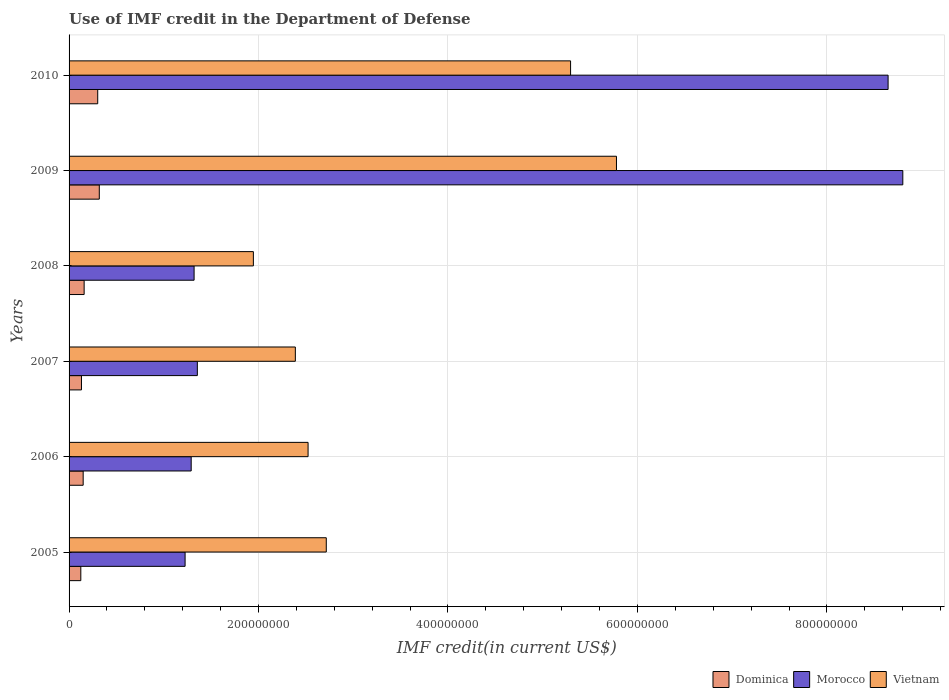How many groups of bars are there?
Your answer should be compact. 6. Are the number of bars per tick equal to the number of legend labels?
Your response must be concise. Yes. Are the number of bars on each tick of the Y-axis equal?
Provide a short and direct response. Yes. How many bars are there on the 5th tick from the bottom?
Offer a terse response. 3. What is the IMF credit in the Department of Defense in Morocco in 2010?
Offer a very short reply. 8.65e+08. Across all years, what is the maximum IMF credit in the Department of Defense in Dominica?
Your response must be concise. 3.19e+07. Across all years, what is the minimum IMF credit in the Department of Defense in Vietnam?
Your response must be concise. 1.95e+08. In which year was the IMF credit in the Department of Defense in Dominica maximum?
Offer a terse response. 2009. What is the total IMF credit in the Department of Defense in Morocco in the graph?
Your response must be concise. 2.26e+09. What is the difference between the IMF credit in the Department of Defense in Vietnam in 2007 and that in 2009?
Give a very brief answer. -3.39e+08. What is the difference between the IMF credit in the Department of Defense in Morocco in 2008 and the IMF credit in the Department of Defense in Dominica in 2007?
Keep it short and to the point. 1.19e+08. What is the average IMF credit in the Department of Defense in Morocco per year?
Your answer should be very brief. 3.77e+08. In the year 2007, what is the difference between the IMF credit in the Department of Defense in Dominica and IMF credit in the Department of Defense in Morocco?
Keep it short and to the point. -1.22e+08. What is the ratio of the IMF credit in the Department of Defense in Morocco in 2009 to that in 2010?
Make the answer very short. 1.02. Is the IMF credit in the Department of Defense in Vietnam in 2006 less than that in 2007?
Ensure brevity in your answer.  No. What is the difference between the highest and the second highest IMF credit in the Department of Defense in Vietnam?
Ensure brevity in your answer.  4.84e+07. What is the difference between the highest and the lowest IMF credit in the Department of Defense in Dominica?
Make the answer very short. 1.95e+07. What does the 2nd bar from the top in 2005 represents?
Your answer should be very brief. Morocco. What does the 3rd bar from the bottom in 2007 represents?
Offer a terse response. Vietnam. Is it the case that in every year, the sum of the IMF credit in the Department of Defense in Dominica and IMF credit in the Department of Defense in Vietnam is greater than the IMF credit in the Department of Defense in Morocco?
Give a very brief answer. No. Are all the bars in the graph horizontal?
Ensure brevity in your answer.  Yes. What is the difference between two consecutive major ticks on the X-axis?
Keep it short and to the point. 2.00e+08. Are the values on the major ticks of X-axis written in scientific E-notation?
Provide a short and direct response. No. Does the graph contain any zero values?
Offer a very short reply. No. Where does the legend appear in the graph?
Your answer should be compact. Bottom right. How are the legend labels stacked?
Give a very brief answer. Horizontal. What is the title of the graph?
Offer a terse response. Use of IMF credit in the Department of Defense. Does "Haiti" appear as one of the legend labels in the graph?
Give a very brief answer. No. What is the label or title of the X-axis?
Provide a short and direct response. IMF credit(in current US$). What is the label or title of the Y-axis?
Your answer should be compact. Years. What is the IMF credit(in current US$) of Dominica in 2005?
Offer a very short reply. 1.24e+07. What is the IMF credit(in current US$) in Morocco in 2005?
Offer a very short reply. 1.22e+08. What is the IMF credit(in current US$) of Vietnam in 2005?
Your response must be concise. 2.72e+08. What is the IMF credit(in current US$) in Dominica in 2006?
Ensure brevity in your answer.  1.49e+07. What is the IMF credit(in current US$) in Morocco in 2006?
Provide a short and direct response. 1.29e+08. What is the IMF credit(in current US$) in Vietnam in 2006?
Your answer should be compact. 2.52e+08. What is the IMF credit(in current US$) in Dominica in 2007?
Provide a short and direct response. 1.31e+07. What is the IMF credit(in current US$) of Morocco in 2007?
Offer a very short reply. 1.35e+08. What is the IMF credit(in current US$) in Vietnam in 2007?
Your answer should be compact. 2.39e+08. What is the IMF credit(in current US$) of Dominica in 2008?
Provide a succinct answer. 1.59e+07. What is the IMF credit(in current US$) in Morocco in 2008?
Your answer should be compact. 1.32e+08. What is the IMF credit(in current US$) in Vietnam in 2008?
Make the answer very short. 1.95e+08. What is the IMF credit(in current US$) of Dominica in 2009?
Your answer should be compact. 3.19e+07. What is the IMF credit(in current US$) in Morocco in 2009?
Keep it short and to the point. 8.80e+08. What is the IMF credit(in current US$) of Vietnam in 2009?
Your response must be concise. 5.78e+08. What is the IMF credit(in current US$) in Dominica in 2010?
Ensure brevity in your answer.  3.02e+07. What is the IMF credit(in current US$) of Morocco in 2010?
Keep it short and to the point. 8.65e+08. What is the IMF credit(in current US$) of Vietnam in 2010?
Provide a short and direct response. 5.29e+08. Across all years, what is the maximum IMF credit(in current US$) in Dominica?
Your answer should be compact. 3.19e+07. Across all years, what is the maximum IMF credit(in current US$) of Morocco?
Your answer should be very brief. 8.80e+08. Across all years, what is the maximum IMF credit(in current US$) in Vietnam?
Offer a very short reply. 5.78e+08. Across all years, what is the minimum IMF credit(in current US$) of Dominica?
Provide a succinct answer. 1.24e+07. Across all years, what is the minimum IMF credit(in current US$) in Morocco?
Give a very brief answer. 1.22e+08. Across all years, what is the minimum IMF credit(in current US$) of Vietnam?
Provide a short and direct response. 1.95e+08. What is the total IMF credit(in current US$) of Dominica in the graph?
Your response must be concise. 1.18e+08. What is the total IMF credit(in current US$) in Morocco in the graph?
Make the answer very short. 2.26e+09. What is the total IMF credit(in current US$) of Vietnam in the graph?
Your response must be concise. 2.06e+09. What is the difference between the IMF credit(in current US$) in Dominica in 2005 and that in 2006?
Your answer should be compact. -2.49e+06. What is the difference between the IMF credit(in current US$) in Morocco in 2005 and that in 2006?
Offer a terse response. -6.44e+06. What is the difference between the IMF credit(in current US$) in Vietnam in 2005 and that in 2006?
Provide a succinct answer. 1.92e+07. What is the difference between the IMF credit(in current US$) in Dominica in 2005 and that in 2007?
Give a very brief answer. -6.87e+05. What is the difference between the IMF credit(in current US$) of Morocco in 2005 and that in 2007?
Your answer should be compact. -1.29e+07. What is the difference between the IMF credit(in current US$) of Vietnam in 2005 and that in 2007?
Give a very brief answer. 3.27e+07. What is the difference between the IMF credit(in current US$) in Dominica in 2005 and that in 2008?
Ensure brevity in your answer.  -3.51e+06. What is the difference between the IMF credit(in current US$) of Morocco in 2005 and that in 2008?
Keep it short and to the point. -9.51e+06. What is the difference between the IMF credit(in current US$) of Vietnam in 2005 and that in 2008?
Give a very brief answer. 7.70e+07. What is the difference between the IMF credit(in current US$) of Dominica in 2005 and that in 2009?
Keep it short and to the point. -1.95e+07. What is the difference between the IMF credit(in current US$) in Morocco in 2005 and that in 2009?
Your answer should be compact. -7.58e+08. What is the difference between the IMF credit(in current US$) of Vietnam in 2005 and that in 2009?
Provide a short and direct response. -3.06e+08. What is the difference between the IMF credit(in current US$) of Dominica in 2005 and that in 2010?
Ensure brevity in your answer.  -1.78e+07. What is the difference between the IMF credit(in current US$) in Morocco in 2005 and that in 2010?
Keep it short and to the point. -7.42e+08. What is the difference between the IMF credit(in current US$) in Vietnam in 2005 and that in 2010?
Provide a succinct answer. -2.58e+08. What is the difference between the IMF credit(in current US$) in Dominica in 2006 and that in 2007?
Give a very brief answer. 1.80e+06. What is the difference between the IMF credit(in current US$) of Morocco in 2006 and that in 2007?
Offer a terse response. -6.50e+06. What is the difference between the IMF credit(in current US$) of Vietnam in 2006 and that in 2007?
Offer a very short reply. 1.34e+07. What is the difference between the IMF credit(in current US$) of Dominica in 2006 and that in 2008?
Provide a succinct answer. -1.03e+06. What is the difference between the IMF credit(in current US$) in Morocco in 2006 and that in 2008?
Offer a terse response. -3.07e+06. What is the difference between the IMF credit(in current US$) in Vietnam in 2006 and that in 2008?
Your response must be concise. 5.78e+07. What is the difference between the IMF credit(in current US$) in Dominica in 2006 and that in 2009?
Your answer should be very brief. -1.70e+07. What is the difference between the IMF credit(in current US$) in Morocco in 2006 and that in 2009?
Give a very brief answer. -7.51e+08. What is the difference between the IMF credit(in current US$) in Vietnam in 2006 and that in 2009?
Give a very brief answer. -3.26e+08. What is the difference between the IMF credit(in current US$) in Dominica in 2006 and that in 2010?
Keep it short and to the point. -1.54e+07. What is the difference between the IMF credit(in current US$) in Morocco in 2006 and that in 2010?
Keep it short and to the point. -7.36e+08. What is the difference between the IMF credit(in current US$) of Vietnam in 2006 and that in 2010?
Keep it short and to the point. -2.77e+08. What is the difference between the IMF credit(in current US$) in Dominica in 2007 and that in 2008?
Make the answer very short. -2.83e+06. What is the difference between the IMF credit(in current US$) in Morocco in 2007 and that in 2008?
Keep it short and to the point. 3.43e+06. What is the difference between the IMF credit(in current US$) of Vietnam in 2007 and that in 2008?
Keep it short and to the point. 4.43e+07. What is the difference between the IMF credit(in current US$) of Dominica in 2007 and that in 2009?
Ensure brevity in your answer.  -1.88e+07. What is the difference between the IMF credit(in current US$) of Morocco in 2007 and that in 2009?
Ensure brevity in your answer.  -7.45e+08. What is the difference between the IMF credit(in current US$) of Vietnam in 2007 and that in 2009?
Your response must be concise. -3.39e+08. What is the difference between the IMF credit(in current US$) in Dominica in 2007 and that in 2010?
Offer a terse response. -1.72e+07. What is the difference between the IMF credit(in current US$) of Morocco in 2007 and that in 2010?
Make the answer very short. -7.29e+08. What is the difference between the IMF credit(in current US$) in Vietnam in 2007 and that in 2010?
Give a very brief answer. -2.91e+08. What is the difference between the IMF credit(in current US$) in Dominica in 2008 and that in 2009?
Provide a short and direct response. -1.60e+07. What is the difference between the IMF credit(in current US$) in Morocco in 2008 and that in 2009?
Your response must be concise. -7.48e+08. What is the difference between the IMF credit(in current US$) of Vietnam in 2008 and that in 2009?
Give a very brief answer. -3.83e+08. What is the difference between the IMF credit(in current US$) in Dominica in 2008 and that in 2010?
Keep it short and to the point. -1.43e+07. What is the difference between the IMF credit(in current US$) in Morocco in 2008 and that in 2010?
Your answer should be compact. -7.33e+08. What is the difference between the IMF credit(in current US$) in Vietnam in 2008 and that in 2010?
Offer a terse response. -3.35e+08. What is the difference between the IMF credit(in current US$) of Dominica in 2009 and that in 2010?
Provide a succinct answer. 1.67e+06. What is the difference between the IMF credit(in current US$) in Morocco in 2009 and that in 2010?
Make the answer very short. 1.55e+07. What is the difference between the IMF credit(in current US$) in Vietnam in 2009 and that in 2010?
Offer a very short reply. 4.84e+07. What is the difference between the IMF credit(in current US$) of Dominica in 2005 and the IMF credit(in current US$) of Morocco in 2006?
Ensure brevity in your answer.  -1.17e+08. What is the difference between the IMF credit(in current US$) in Dominica in 2005 and the IMF credit(in current US$) in Vietnam in 2006?
Provide a succinct answer. -2.40e+08. What is the difference between the IMF credit(in current US$) of Morocco in 2005 and the IMF credit(in current US$) of Vietnam in 2006?
Provide a succinct answer. -1.30e+08. What is the difference between the IMF credit(in current US$) of Dominica in 2005 and the IMF credit(in current US$) of Morocco in 2007?
Ensure brevity in your answer.  -1.23e+08. What is the difference between the IMF credit(in current US$) of Dominica in 2005 and the IMF credit(in current US$) of Vietnam in 2007?
Your answer should be compact. -2.26e+08. What is the difference between the IMF credit(in current US$) of Morocco in 2005 and the IMF credit(in current US$) of Vietnam in 2007?
Offer a very short reply. -1.16e+08. What is the difference between the IMF credit(in current US$) in Dominica in 2005 and the IMF credit(in current US$) in Morocco in 2008?
Ensure brevity in your answer.  -1.20e+08. What is the difference between the IMF credit(in current US$) of Dominica in 2005 and the IMF credit(in current US$) of Vietnam in 2008?
Provide a succinct answer. -1.82e+08. What is the difference between the IMF credit(in current US$) in Morocco in 2005 and the IMF credit(in current US$) in Vietnam in 2008?
Offer a very short reply. -7.21e+07. What is the difference between the IMF credit(in current US$) in Dominica in 2005 and the IMF credit(in current US$) in Morocco in 2009?
Give a very brief answer. -8.68e+08. What is the difference between the IMF credit(in current US$) of Dominica in 2005 and the IMF credit(in current US$) of Vietnam in 2009?
Your answer should be very brief. -5.65e+08. What is the difference between the IMF credit(in current US$) of Morocco in 2005 and the IMF credit(in current US$) of Vietnam in 2009?
Your answer should be compact. -4.55e+08. What is the difference between the IMF credit(in current US$) of Dominica in 2005 and the IMF credit(in current US$) of Morocco in 2010?
Ensure brevity in your answer.  -8.52e+08. What is the difference between the IMF credit(in current US$) in Dominica in 2005 and the IMF credit(in current US$) in Vietnam in 2010?
Give a very brief answer. -5.17e+08. What is the difference between the IMF credit(in current US$) in Morocco in 2005 and the IMF credit(in current US$) in Vietnam in 2010?
Provide a succinct answer. -4.07e+08. What is the difference between the IMF credit(in current US$) in Dominica in 2006 and the IMF credit(in current US$) in Morocco in 2007?
Offer a terse response. -1.21e+08. What is the difference between the IMF credit(in current US$) in Dominica in 2006 and the IMF credit(in current US$) in Vietnam in 2007?
Your response must be concise. -2.24e+08. What is the difference between the IMF credit(in current US$) in Morocco in 2006 and the IMF credit(in current US$) in Vietnam in 2007?
Offer a very short reply. -1.10e+08. What is the difference between the IMF credit(in current US$) in Dominica in 2006 and the IMF credit(in current US$) in Morocco in 2008?
Provide a short and direct response. -1.17e+08. What is the difference between the IMF credit(in current US$) of Dominica in 2006 and the IMF credit(in current US$) of Vietnam in 2008?
Offer a very short reply. -1.80e+08. What is the difference between the IMF credit(in current US$) of Morocco in 2006 and the IMF credit(in current US$) of Vietnam in 2008?
Provide a succinct answer. -6.57e+07. What is the difference between the IMF credit(in current US$) in Dominica in 2006 and the IMF credit(in current US$) in Morocco in 2009?
Give a very brief answer. -8.65e+08. What is the difference between the IMF credit(in current US$) in Dominica in 2006 and the IMF credit(in current US$) in Vietnam in 2009?
Provide a short and direct response. -5.63e+08. What is the difference between the IMF credit(in current US$) in Morocco in 2006 and the IMF credit(in current US$) in Vietnam in 2009?
Offer a terse response. -4.49e+08. What is the difference between the IMF credit(in current US$) in Dominica in 2006 and the IMF credit(in current US$) in Morocco in 2010?
Your response must be concise. -8.50e+08. What is the difference between the IMF credit(in current US$) in Dominica in 2006 and the IMF credit(in current US$) in Vietnam in 2010?
Make the answer very short. -5.15e+08. What is the difference between the IMF credit(in current US$) in Morocco in 2006 and the IMF credit(in current US$) in Vietnam in 2010?
Provide a short and direct response. -4.01e+08. What is the difference between the IMF credit(in current US$) in Dominica in 2007 and the IMF credit(in current US$) in Morocco in 2008?
Your answer should be compact. -1.19e+08. What is the difference between the IMF credit(in current US$) in Dominica in 2007 and the IMF credit(in current US$) in Vietnam in 2008?
Offer a terse response. -1.81e+08. What is the difference between the IMF credit(in current US$) of Morocco in 2007 and the IMF credit(in current US$) of Vietnam in 2008?
Your answer should be compact. -5.92e+07. What is the difference between the IMF credit(in current US$) of Dominica in 2007 and the IMF credit(in current US$) of Morocco in 2009?
Offer a terse response. -8.67e+08. What is the difference between the IMF credit(in current US$) of Dominica in 2007 and the IMF credit(in current US$) of Vietnam in 2009?
Your answer should be compact. -5.65e+08. What is the difference between the IMF credit(in current US$) in Morocco in 2007 and the IMF credit(in current US$) in Vietnam in 2009?
Provide a succinct answer. -4.42e+08. What is the difference between the IMF credit(in current US$) of Dominica in 2007 and the IMF credit(in current US$) of Morocco in 2010?
Give a very brief answer. -8.52e+08. What is the difference between the IMF credit(in current US$) in Dominica in 2007 and the IMF credit(in current US$) in Vietnam in 2010?
Keep it short and to the point. -5.16e+08. What is the difference between the IMF credit(in current US$) in Morocco in 2007 and the IMF credit(in current US$) in Vietnam in 2010?
Provide a short and direct response. -3.94e+08. What is the difference between the IMF credit(in current US$) of Dominica in 2008 and the IMF credit(in current US$) of Morocco in 2009?
Provide a succinct answer. -8.64e+08. What is the difference between the IMF credit(in current US$) of Dominica in 2008 and the IMF credit(in current US$) of Vietnam in 2009?
Keep it short and to the point. -5.62e+08. What is the difference between the IMF credit(in current US$) in Morocco in 2008 and the IMF credit(in current US$) in Vietnam in 2009?
Give a very brief answer. -4.46e+08. What is the difference between the IMF credit(in current US$) of Dominica in 2008 and the IMF credit(in current US$) of Morocco in 2010?
Give a very brief answer. -8.49e+08. What is the difference between the IMF credit(in current US$) in Dominica in 2008 and the IMF credit(in current US$) in Vietnam in 2010?
Provide a short and direct response. -5.14e+08. What is the difference between the IMF credit(in current US$) in Morocco in 2008 and the IMF credit(in current US$) in Vietnam in 2010?
Provide a succinct answer. -3.97e+08. What is the difference between the IMF credit(in current US$) in Dominica in 2009 and the IMF credit(in current US$) in Morocco in 2010?
Offer a terse response. -8.33e+08. What is the difference between the IMF credit(in current US$) of Dominica in 2009 and the IMF credit(in current US$) of Vietnam in 2010?
Your response must be concise. -4.98e+08. What is the difference between the IMF credit(in current US$) of Morocco in 2009 and the IMF credit(in current US$) of Vietnam in 2010?
Make the answer very short. 3.51e+08. What is the average IMF credit(in current US$) in Dominica per year?
Offer a terse response. 1.97e+07. What is the average IMF credit(in current US$) of Morocco per year?
Offer a terse response. 3.77e+08. What is the average IMF credit(in current US$) of Vietnam per year?
Your response must be concise. 3.44e+08. In the year 2005, what is the difference between the IMF credit(in current US$) in Dominica and IMF credit(in current US$) in Morocco?
Offer a very short reply. -1.10e+08. In the year 2005, what is the difference between the IMF credit(in current US$) in Dominica and IMF credit(in current US$) in Vietnam?
Provide a succinct answer. -2.59e+08. In the year 2005, what is the difference between the IMF credit(in current US$) of Morocco and IMF credit(in current US$) of Vietnam?
Ensure brevity in your answer.  -1.49e+08. In the year 2006, what is the difference between the IMF credit(in current US$) of Dominica and IMF credit(in current US$) of Morocco?
Your answer should be very brief. -1.14e+08. In the year 2006, what is the difference between the IMF credit(in current US$) in Dominica and IMF credit(in current US$) in Vietnam?
Make the answer very short. -2.37e+08. In the year 2006, what is the difference between the IMF credit(in current US$) in Morocco and IMF credit(in current US$) in Vietnam?
Offer a terse response. -1.23e+08. In the year 2007, what is the difference between the IMF credit(in current US$) in Dominica and IMF credit(in current US$) in Morocco?
Keep it short and to the point. -1.22e+08. In the year 2007, what is the difference between the IMF credit(in current US$) of Dominica and IMF credit(in current US$) of Vietnam?
Provide a succinct answer. -2.26e+08. In the year 2007, what is the difference between the IMF credit(in current US$) in Morocco and IMF credit(in current US$) in Vietnam?
Make the answer very short. -1.03e+08. In the year 2008, what is the difference between the IMF credit(in current US$) in Dominica and IMF credit(in current US$) in Morocco?
Provide a short and direct response. -1.16e+08. In the year 2008, what is the difference between the IMF credit(in current US$) in Dominica and IMF credit(in current US$) in Vietnam?
Give a very brief answer. -1.79e+08. In the year 2008, what is the difference between the IMF credit(in current US$) of Morocco and IMF credit(in current US$) of Vietnam?
Your answer should be very brief. -6.26e+07. In the year 2009, what is the difference between the IMF credit(in current US$) in Dominica and IMF credit(in current US$) in Morocco?
Ensure brevity in your answer.  -8.48e+08. In the year 2009, what is the difference between the IMF credit(in current US$) in Dominica and IMF credit(in current US$) in Vietnam?
Offer a terse response. -5.46e+08. In the year 2009, what is the difference between the IMF credit(in current US$) in Morocco and IMF credit(in current US$) in Vietnam?
Offer a very short reply. 3.02e+08. In the year 2010, what is the difference between the IMF credit(in current US$) of Dominica and IMF credit(in current US$) of Morocco?
Provide a succinct answer. -8.34e+08. In the year 2010, what is the difference between the IMF credit(in current US$) of Dominica and IMF credit(in current US$) of Vietnam?
Provide a succinct answer. -4.99e+08. In the year 2010, what is the difference between the IMF credit(in current US$) of Morocco and IMF credit(in current US$) of Vietnam?
Provide a short and direct response. 3.35e+08. What is the ratio of the IMF credit(in current US$) in Dominica in 2005 to that in 2006?
Make the answer very short. 0.83. What is the ratio of the IMF credit(in current US$) in Morocco in 2005 to that in 2006?
Provide a short and direct response. 0.95. What is the ratio of the IMF credit(in current US$) of Vietnam in 2005 to that in 2006?
Your answer should be compact. 1.08. What is the ratio of the IMF credit(in current US$) in Dominica in 2005 to that in 2007?
Keep it short and to the point. 0.95. What is the ratio of the IMF credit(in current US$) of Morocco in 2005 to that in 2007?
Ensure brevity in your answer.  0.9. What is the ratio of the IMF credit(in current US$) in Vietnam in 2005 to that in 2007?
Ensure brevity in your answer.  1.14. What is the ratio of the IMF credit(in current US$) of Dominica in 2005 to that in 2008?
Give a very brief answer. 0.78. What is the ratio of the IMF credit(in current US$) in Morocco in 2005 to that in 2008?
Offer a very short reply. 0.93. What is the ratio of the IMF credit(in current US$) in Vietnam in 2005 to that in 2008?
Your answer should be very brief. 1.4. What is the ratio of the IMF credit(in current US$) of Dominica in 2005 to that in 2009?
Ensure brevity in your answer.  0.39. What is the ratio of the IMF credit(in current US$) of Morocco in 2005 to that in 2009?
Your answer should be very brief. 0.14. What is the ratio of the IMF credit(in current US$) of Vietnam in 2005 to that in 2009?
Offer a very short reply. 0.47. What is the ratio of the IMF credit(in current US$) of Dominica in 2005 to that in 2010?
Your answer should be very brief. 0.41. What is the ratio of the IMF credit(in current US$) of Morocco in 2005 to that in 2010?
Provide a short and direct response. 0.14. What is the ratio of the IMF credit(in current US$) of Vietnam in 2005 to that in 2010?
Your response must be concise. 0.51. What is the ratio of the IMF credit(in current US$) in Dominica in 2006 to that in 2007?
Give a very brief answer. 1.14. What is the ratio of the IMF credit(in current US$) of Morocco in 2006 to that in 2007?
Offer a very short reply. 0.95. What is the ratio of the IMF credit(in current US$) of Vietnam in 2006 to that in 2007?
Keep it short and to the point. 1.06. What is the ratio of the IMF credit(in current US$) in Dominica in 2006 to that in 2008?
Make the answer very short. 0.94. What is the ratio of the IMF credit(in current US$) of Morocco in 2006 to that in 2008?
Your answer should be very brief. 0.98. What is the ratio of the IMF credit(in current US$) of Vietnam in 2006 to that in 2008?
Your response must be concise. 1.3. What is the ratio of the IMF credit(in current US$) in Dominica in 2006 to that in 2009?
Make the answer very short. 0.47. What is the ratio of the IMF credit(in current US$) in Morocco in 2006 to that in 2009?
Give a very brief answer. 0.15. What is the ratio of the IMF credit(in current US$) in Vietnam in 2006 to that in 2009?
Your response must be concise. 0.44. What is the ratio of the IMF credit(in current US$) of Dominica in 2006 to that in 2010?
Make the answer very short. 0.49. What is the ratio of the IMF credit(in current US$) of Morocco in 2006 to that in 2010?
Provide a succinct answer. 0.15. What is the ratio of the IMF credit(in current US$) in Vietnam in 2006 to that in 2010?
Offer a very short reply. 0.48. What is the ratio of the IMF credit(in current US$) in Dominica in 2007 to that in 2008?
Provide a short and direct response. 0.82. What is the ratio of the IMF credit(in current US$) in Morocco in 2007 to that in 2008?
Your response must be concise. 1.03. What is the ratio of the IMF credit(in current US$) in Vietnam in 2007 to that in 2008?
Ensure brevity in your answer.  1.23. What is the ratio of the IMF credit(in current US$) in Dominica in 2007 to that in 2009?
Offer a very short reply. 0.41. What is the ratio of the IMF credit(in current US$) in Morocco in 2007 to that in 2009?
Keep it short and to the point. 0.15. What is the ratio of the IMF credit(in current US$) in Vietnam in 2007 to that in 2009?
Your answer should be compact. 0.41. What is the ratio of the IMF credit(in current US$) in Dominica in 2007 to that in 2010?
Give a very brief answer. 0.43. What is the ratio of the IMF credit(in current US$) in Morocco in 2007 to that in 2010?
Ensure brevity in your answer.  0.16. What is the ratio of the IMF credit(in current US$) of Vietnam in 2007 to that in 2010?
Ensure brevity in your answer.  0.45. What is the ratio of the IMF credit(in current US$) of Dominica in 2008 to that in 2009?
Your response must be concise. 0.5. What is the ratio of the IMF credit(in current US$) of Vietnam in 2008 to that in 2009?
Offer a terse response. 0.34. What is the ratio of the IMF credit(in current US$) of Dominica in 2008 to that in 2010?
Offer a terse response. 0.53. What is the ratio of the IMF credit(in current US$) in Morocco in 2008 to that in 2010?
Your response must be concise. 0.15. What is the ratio of the IMF credit(in current US$) of Vietnam in 2008 to that in 2010?
Your answer should be very brief. 0.37. What is the ratio of the IMF credit(in current US$) in Dominica in 2009 to that in 2010?
Provide a short and direct response. 1.06. What is the ratio of the IMF credit(in current US$) of Morocco in 2009 to that in 2010?
Provide a short and direct response. 1.02. What is the ratio of the IMF credit(in current US$) of Vietnam in 2009 to that in 2010?
Provide a succinct answer. 1.09. What is the difference between the highest and the second highest IMF credit(in current US$) of Dominica?
Give a very brief answer. 1.67e+06. What is the difference between the highest and the second highest IMF credit(in current US$) of Morocco?
Offer a very short reply. 1.55e+07. What is the difference between the highest and the second highest IMF credit(in current US$) of Vietnam?
Provide a short and direct response. 4.84e+07. What is the difference between the highest and the lowest IMF credit(in current US$) in Dominica?
Offer a terse response. 1.95e+07. What is the difference between the highest and the lowest IMF credit(in current US$) of Morocco?
Provide a short and direct response. 7.58e+08. What is the difference between the highest and the lowest IMF credit(in current US$) of Vietnam?
Provide a short and direct response. 3.83e+08. 